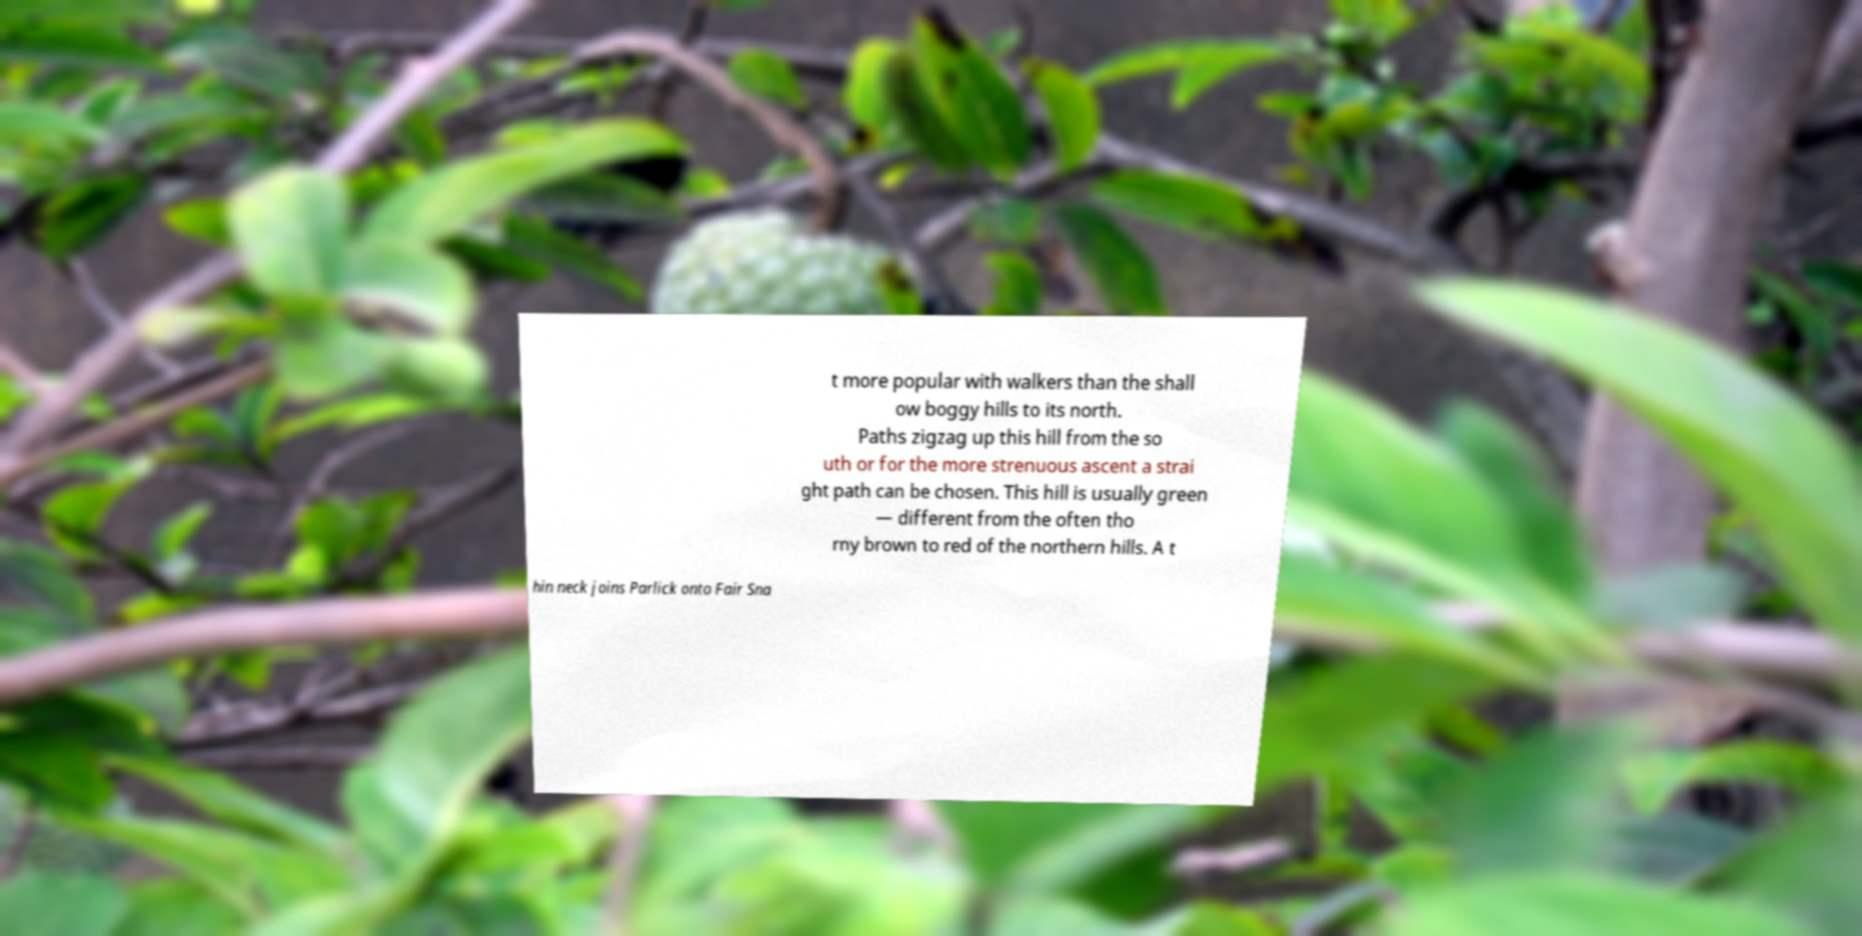Please identify and transcribe the text found in this image. t more popular with walkers than the shall ow boggy hills to its north. Paths zigzag up this hill from the so uth or for the more strenuous ascent a strai ght path can be chosen. This hill is usually green — different from the often tho rny brown to red of the northern hills. A t hin neck joins Parlick onto Fair Sna 